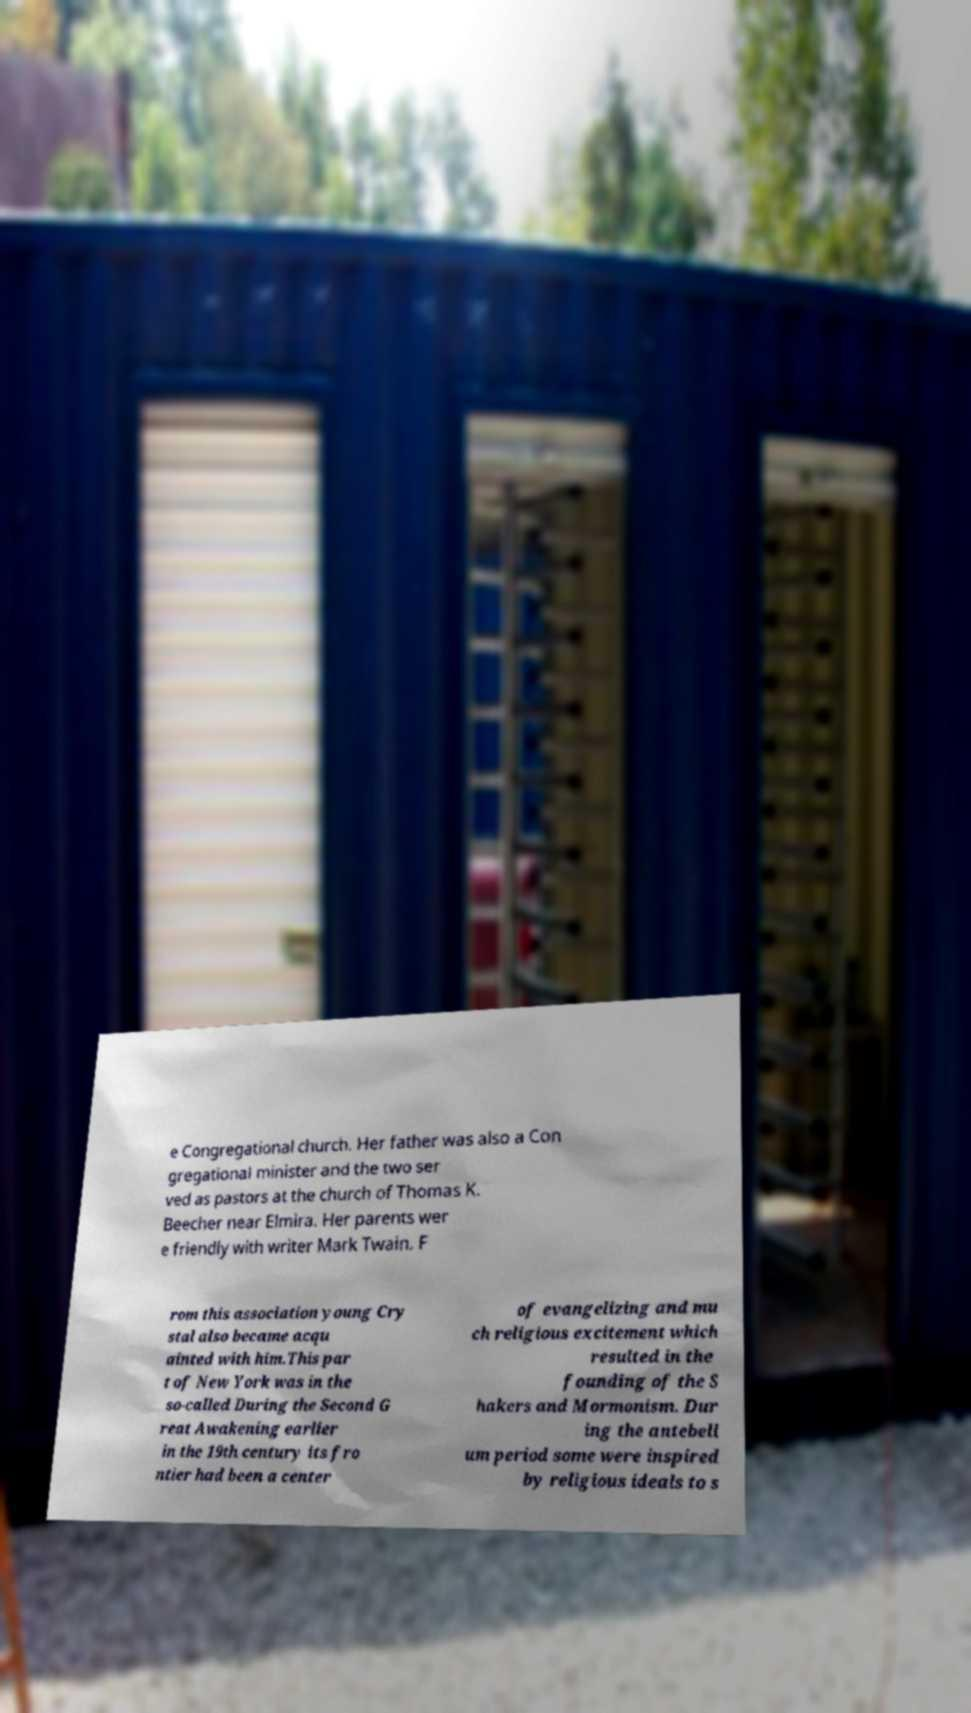Can you read and provide the text displayed in the image?This photo seems to have some interesting text. Can you extract and type it out for me? e Congregational church. Her father was also a Con gregational minister and the two ser ved as pastors at the church of Thomas K. Beecher near Elmira. Her parents wer e friendly with writer Mark Twain. F rom this association young Cry stal also became acqu ainted with him.This par t of New York was in the so-called During the Second G reat Awakening earlier in the 19th century its fro ntier had been a center of evangelizing and mu ch religious excitement which resulted in the founding of the S hakers and Mormonism. Dur ing the antebell um period some were inspired by religious ideals to s 